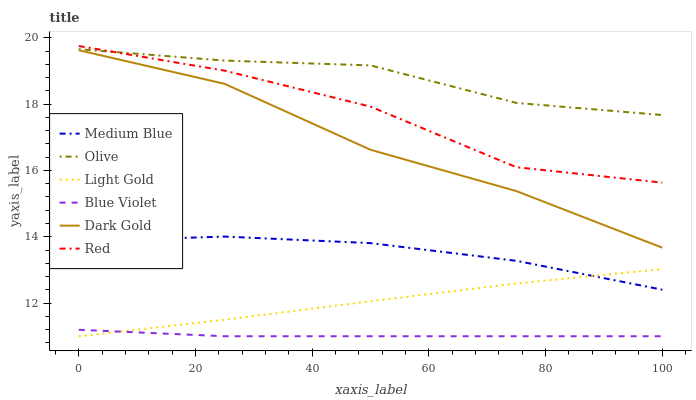Does Blue Violet have the minimum area under the curve?
Answer yes or no. Yes. Does Olive have the maximum area under the curve?
Answer yes or no. Yes. Does Medium Blue have the minimum area under the curve?
Answer yes or no. No. Does Medium Blue have the maximum area under the curve?
Answer yes or no. No. Is Light Gold the smoothest?
Answer yes or no. Yes. Is Red the roughest?
Answer yes or no. Yes. Is Medium Blue the smoothest?
Answer yes or no. No. Is Medium Blue the roughest?
Answer yes or no. No. Does Blue Violet have the lowest value?
Answer yes or no. Yes. Does Medium Blue have the lowest value?
Answer yes or no. No. Does Red have the highest value?
Answer yes or no. Yes. Does Medium Blue have the highest value?
Answer yes or no. No. Is Blue Violet less than Olive?
Answer yes or no. Yes. Is Olive greater than Light Gold?
Answer yes or no. Yes. Does Medium Blue intersect Light Gold?
Answer yes or no. Yes. Is Medium Blue less than Light Gold?
Answer yes or no. No. Is Medium Blue greater than Light Gold?
Answer yes or no. No. Does Blue Violet intersect Olive?
Answer yes or no. No. 